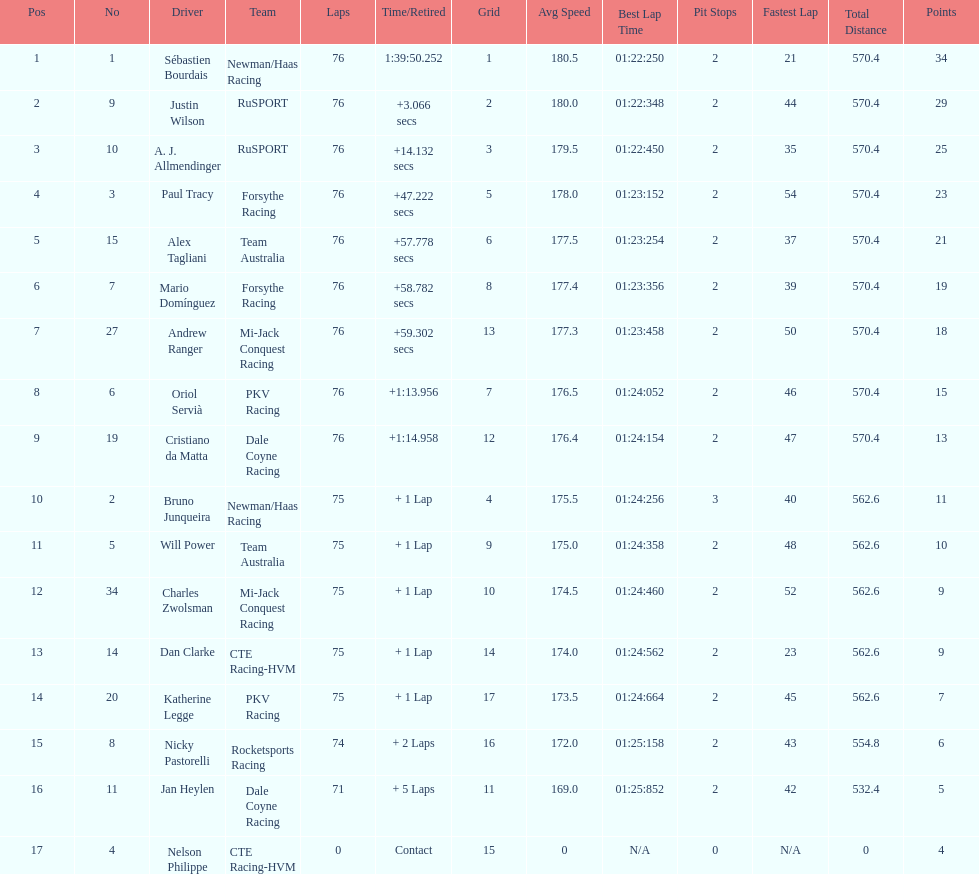How many positions are held by canada? 3. 